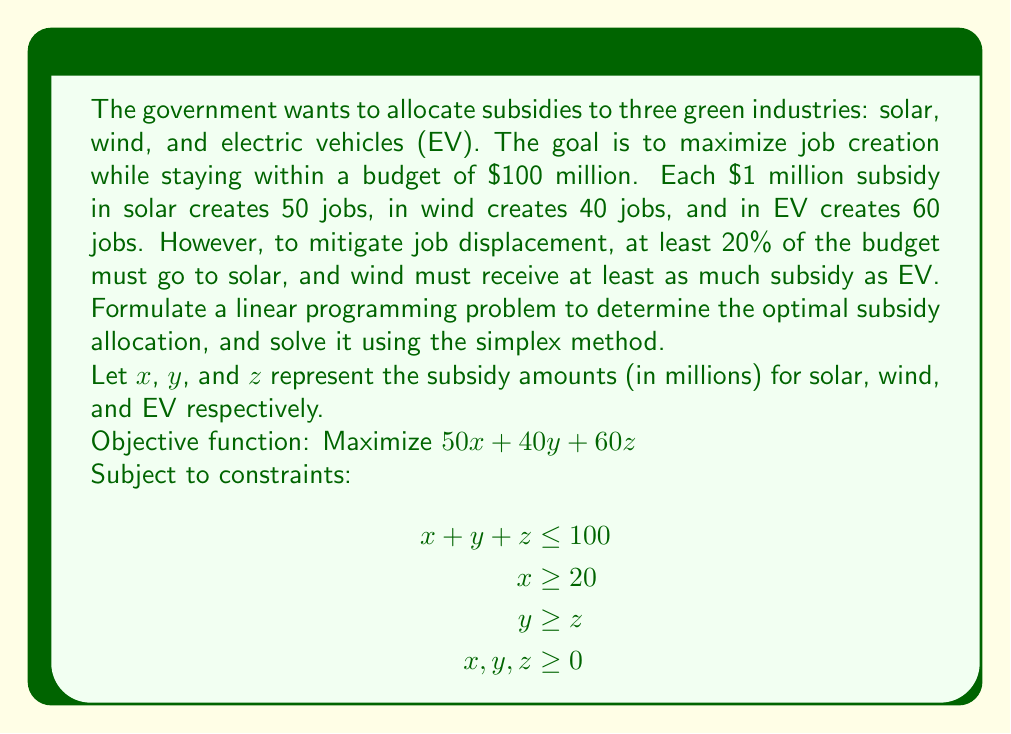Help me with this question. To solve this linear programming problem using the simplex method, we follow these steps:

1) First, convert the problem to standard form by introducing slack variables:

   Maximize $50x + 40y + 60z + 0s_1 + 0s_2 + 0s_3$
   Subject to:
   $$\begin{aligned}
   x + y + z + s_1 &= 100 \\
   x - s_2 &= 20 \\
   y - z - s_3 &= 0 \\
   x, y, z, s_1, s_2, s_3 &\geq 0
   \end{aligned}$$

2) Set up the initial simplex tableau:

   $$\begin{array}{c|cccccc|c}
   & x & y & z & s_1 & s_2 & s_3 & RHS \\
   \hline
   s_1 & 1 & 1 & 1 & 1 & 0 & 0 & 100 \\
   x & 1 & 0 & 0 & 0 & -1 & 0 & 20 \\
   s_3 & 0 & 1 & -1 & 0 & 0 & 1 & 0 \\
   \hline
   -z & -50 & -40 & -60 & 0 & 0 & 0 & 0
   \end{array}$$

3) The most negative entry in the bottom row is -60, corresponding to the z column. This is our pivot column.

4) Calculate the ratios for the pivot row:
   $100/1 = 100$ (s1 row)
   $20/0 = \infty$ (x row)
   $0/-1 = 0$ (s3 row)

   The smallest non-negative ratio is 0, so the s3 row is our pivot row.

5) Perform row operations to make the pivot element 1 and all other entries in the pivot column 0:

   $$\begin{array}{c|cccccc|c}
   & x & y & z & s_1 & s_2 & s_3 & RHS \\
   \hline
   s_1 & 1 & 0 & 0 & 1 & 0 & -1 & 100 \\
   x & 1 & 0 & 0 & 0 & -1 & 0 & 20 \\
   z & 0 & -1 & 1 & 0 & 0 & -1 & 0 \\
   \hline
   -z & -50 & 20 & 0 & 0 & 0 & 60 & 0
   \end{array}$$

6) Repeat steps 3-5 until there are no negative entries in the bottom row. After two more iterations, we get:

   $$\begin{array}{c|cccccc|c}
   & x & y & z & s_1 & s_2 & s_3 & RHS \\
   \hline
   y & 0 & 1 & 0 & 0 & 1 & -1 & 40 \\
   x & 1 & 0 & 0 & 0 & -1 & 0 & 20 \\
   z & 0 & 0 & 1 & 0 & 1 & -1 & 40 \\
   \hline
   -z & 0 & 0 & 0 & 0 & 10 & 20 & 5000
   \end{array}$$

7) This is the optimal solution. Reading from the RHS column:
   $x = 20, y = 40, z = 40$

8) The maximum number of jobs created is 5000.
Answer: Optimal subsidy allocation: Solar $20 million, Wind $40 million, EV $40 million. Maximum jobs created: 5000. 